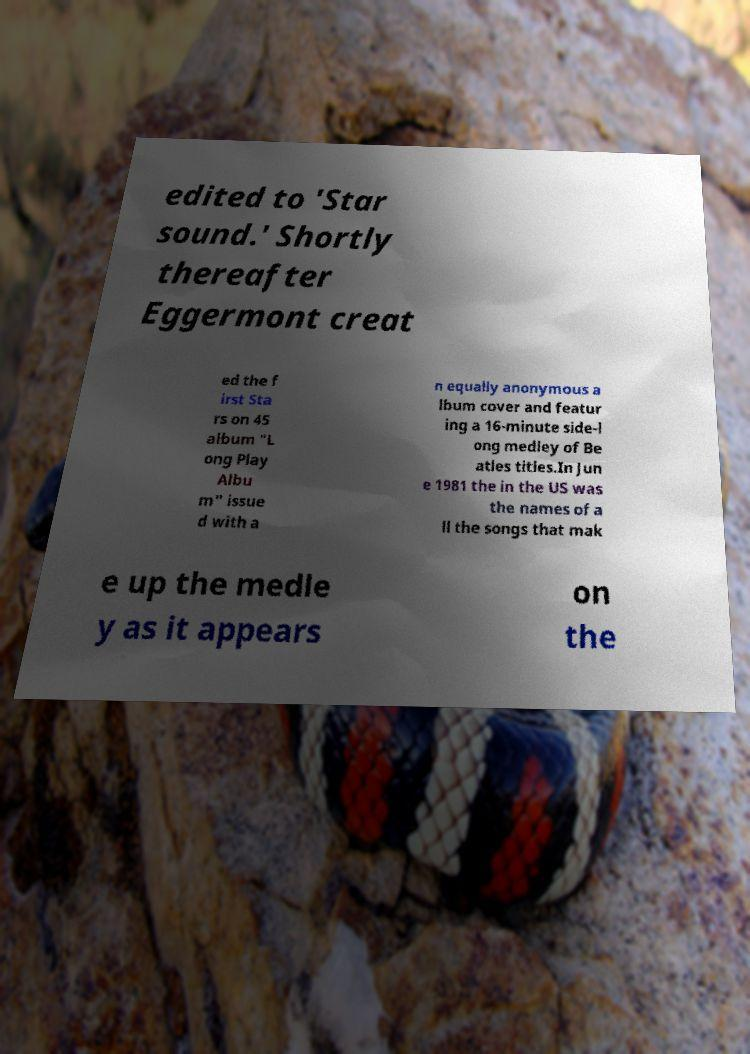Can you read and provide the text displayed in the image?This photo seems to have some interesting text. Can you extract and type it out for me? edited to 'Star sound.' Shortly thereafter Eggermont creat ed the f irst Sta rs on 45 album "L ong Play Albu m" issue d with a n equally anonymous a lbum cover and featur ing a 16-minute side-l ong medley of Be atles titles.In Jun e 1981 the in the US was the names of a ll the songs that mak e up the medle y as it appears on the 